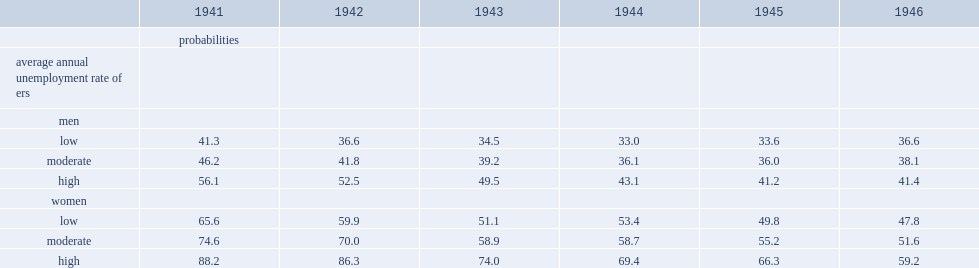For example, for women born in 1941, who resided in an er with high unemployment, what is the percentage of probability? 88.2. In comparison, what is the probability for their counterparts in ers with low unemployment of women? 65.6. For men, what is the percentage of an er with high unemployment of men in 1941? 56.1. For men, what is the percentage of an er with low unemployment of men in 1941? 41.3. Give me the full table as a dictionary. {'header': ['', '1941', '1942', '1943', '1944', '1945', '1946'], 'rows': [['', 'probabilities', '', '', '', '', ''], ['average annual unemployment rate of ers', '', '', '', '', '', ''], ['men', '', '', '', '', '', ''], ['low', '41.3', '36.6', '34.5', '33.0', '33.6', '36.6'], ['moderate', '46.2', '41.8', '39.2', '36.1', '36.0', '38.1'], ['high', '56.1', '52.5', '49.5', '43.1', '41.2', '41.4'], ['women', '', '', '', '', '', ''], ['low', '65.6', '59.9', '51.1', '53.4', '49.8', '47.8'], ['moderate', '74.6', '70.0', '58.9', '58.7', '55.2', '51.6'], ['high', '88.2', '86.3', '74.0', '69.4', '66.3', '59.2']]} 